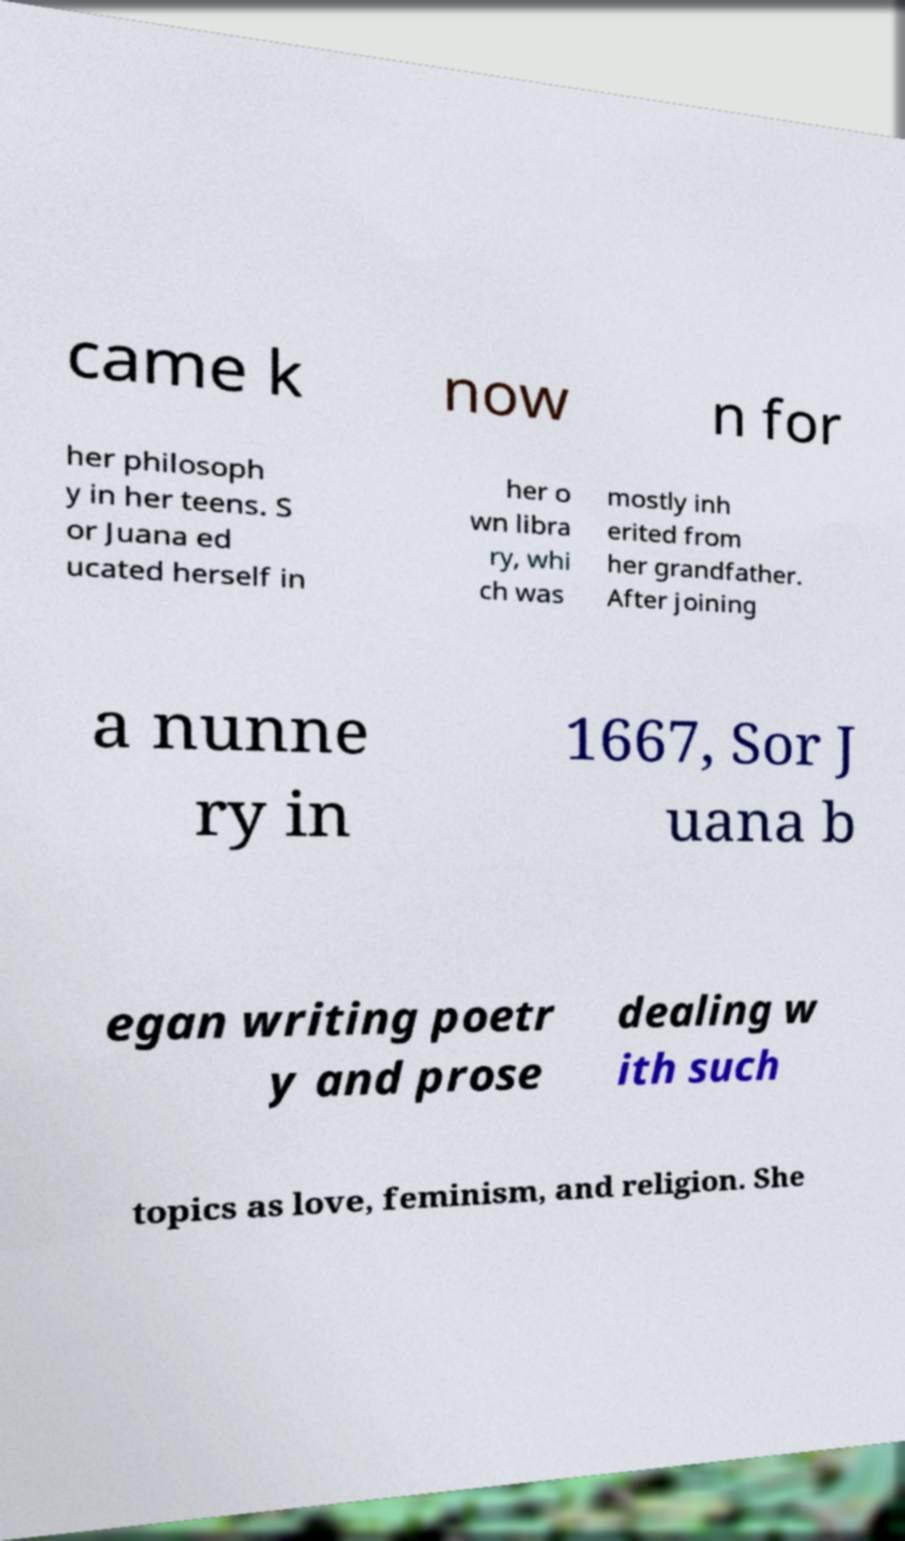Can you accurately transcribe the text from the provided image for me? came k now n for her philosoph y in her teens. S or Juana ed ucated herself in her o wn libra ry, whi ch was mostly inh erited from her grandfather. After joining a nunne ry in 1667, Sor J uana b egan writing poetr y and prose dealing w ith such topics as love, feminism, and religion. She 